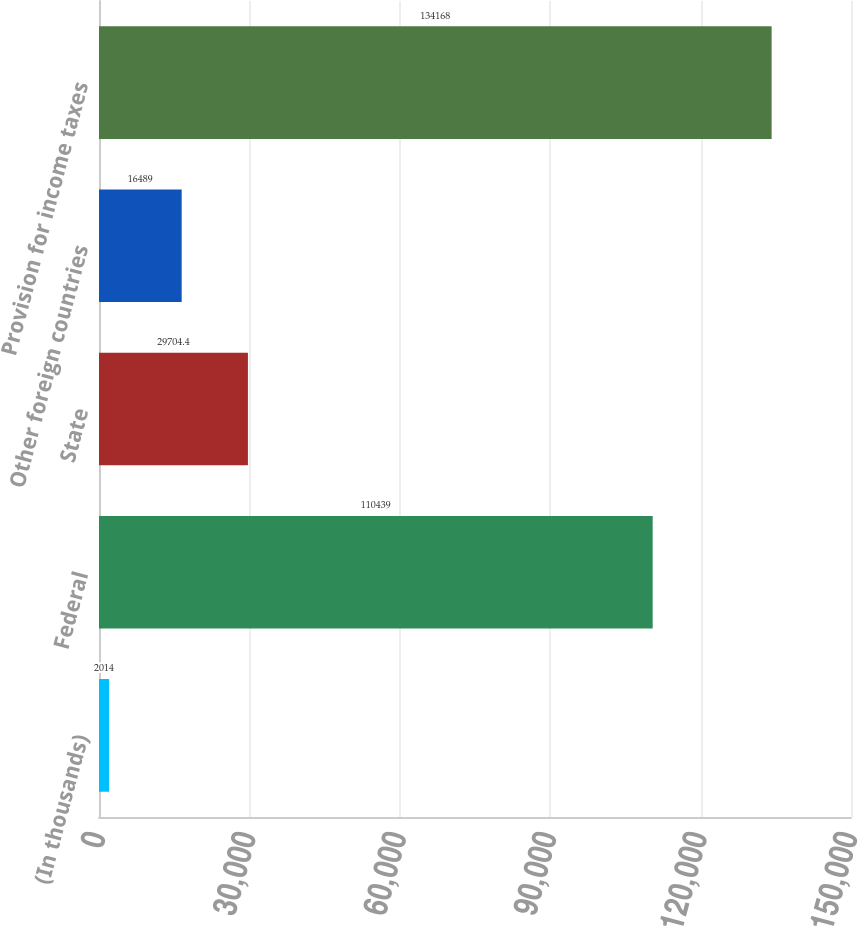Convert chart to OTSL. <chart><loc_0><loc_0><loc_500><loc_500><bar_chart><fcel>(In thousands)<fcel>Federal<fcel>State<fcel>Other foreign countries<fcel>Provision for income taxes<nl><fcel>2014<fcel>110439<fcel>29704.4<fcel>16489<fcel>134168<nl></chart> 